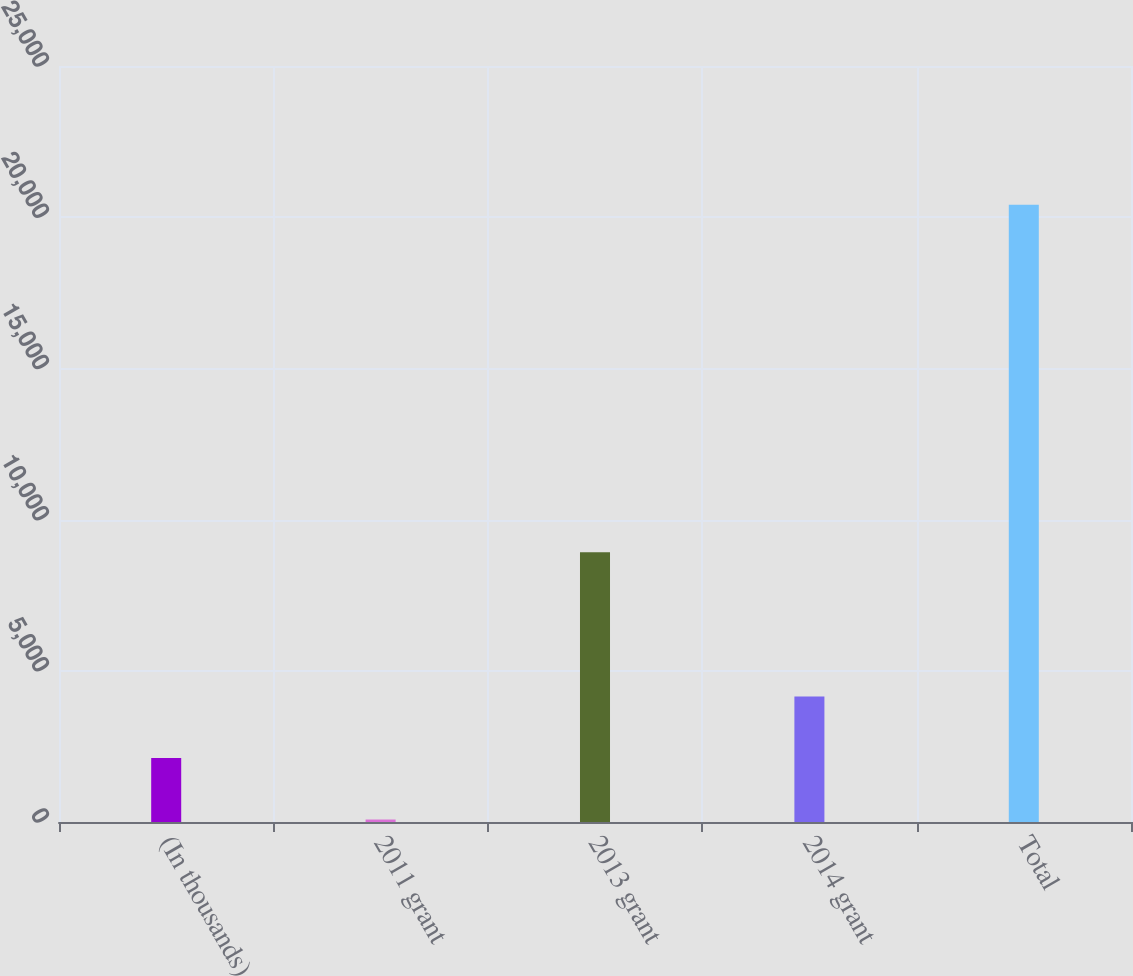Convert chart. <chart><loc_0><loc_0><loc_500><loc_500><bar_chart><fcel>(In thousands)<fcel>2011 grant<fcel>2013 grant<fcel>2014 grant<fcel>Total<nl><fcel>2115.1<fcel>82<fcel>8918<fcel>4148.2<fcel>20413<nl></chart> 